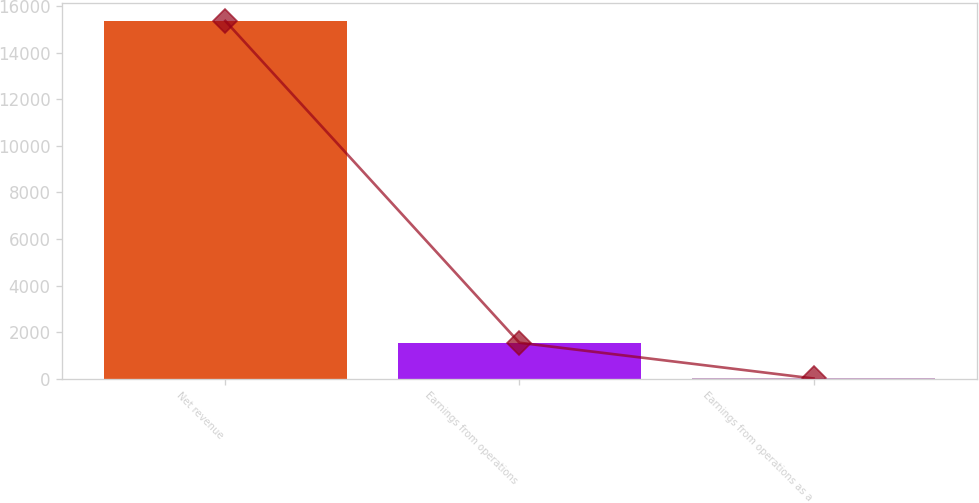<chart> <loc_0><loc_0><loc_500><loc_500><bar_chart><fcel>Net revenue<fcel>Earnings from operations<fcel>Earnings from operations as a<nl><fcel>15359<fcel>1544.81<fcel>9.9<nl></chart> 